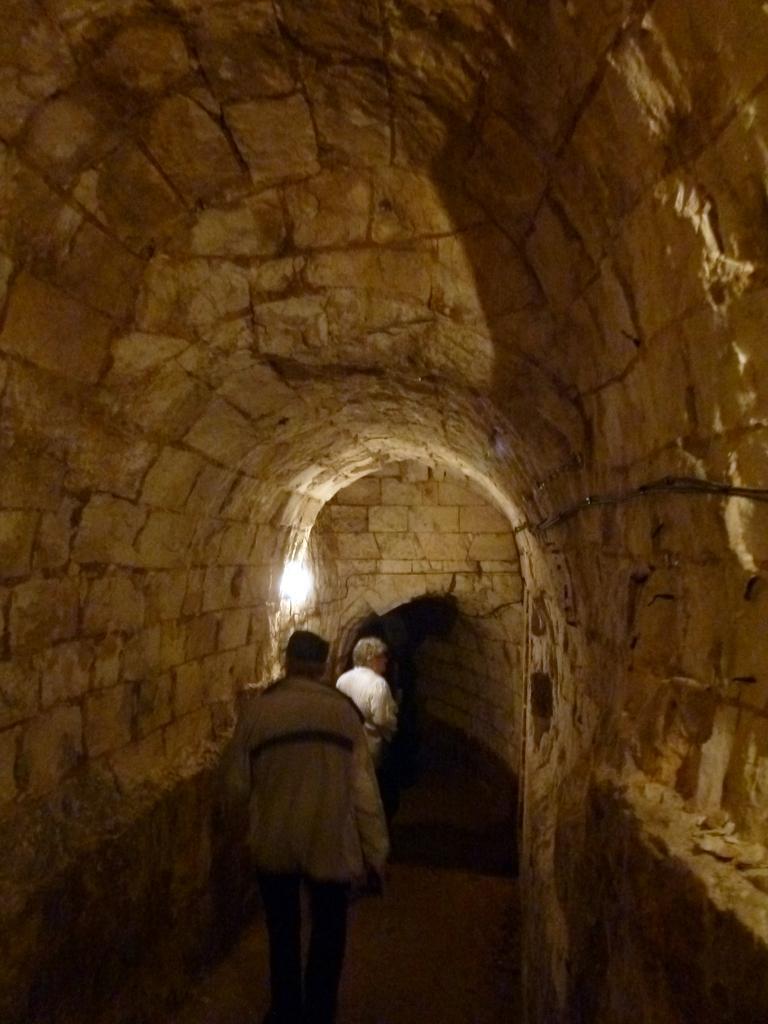Describe this image in one or two sentences. This picture is an inside view of a cave. In the center of the image we can see two mens are walking. At the top of the image we can see the roof. In the background of the image we can see the wall and light. At the bottom of the image we can see the floor. 